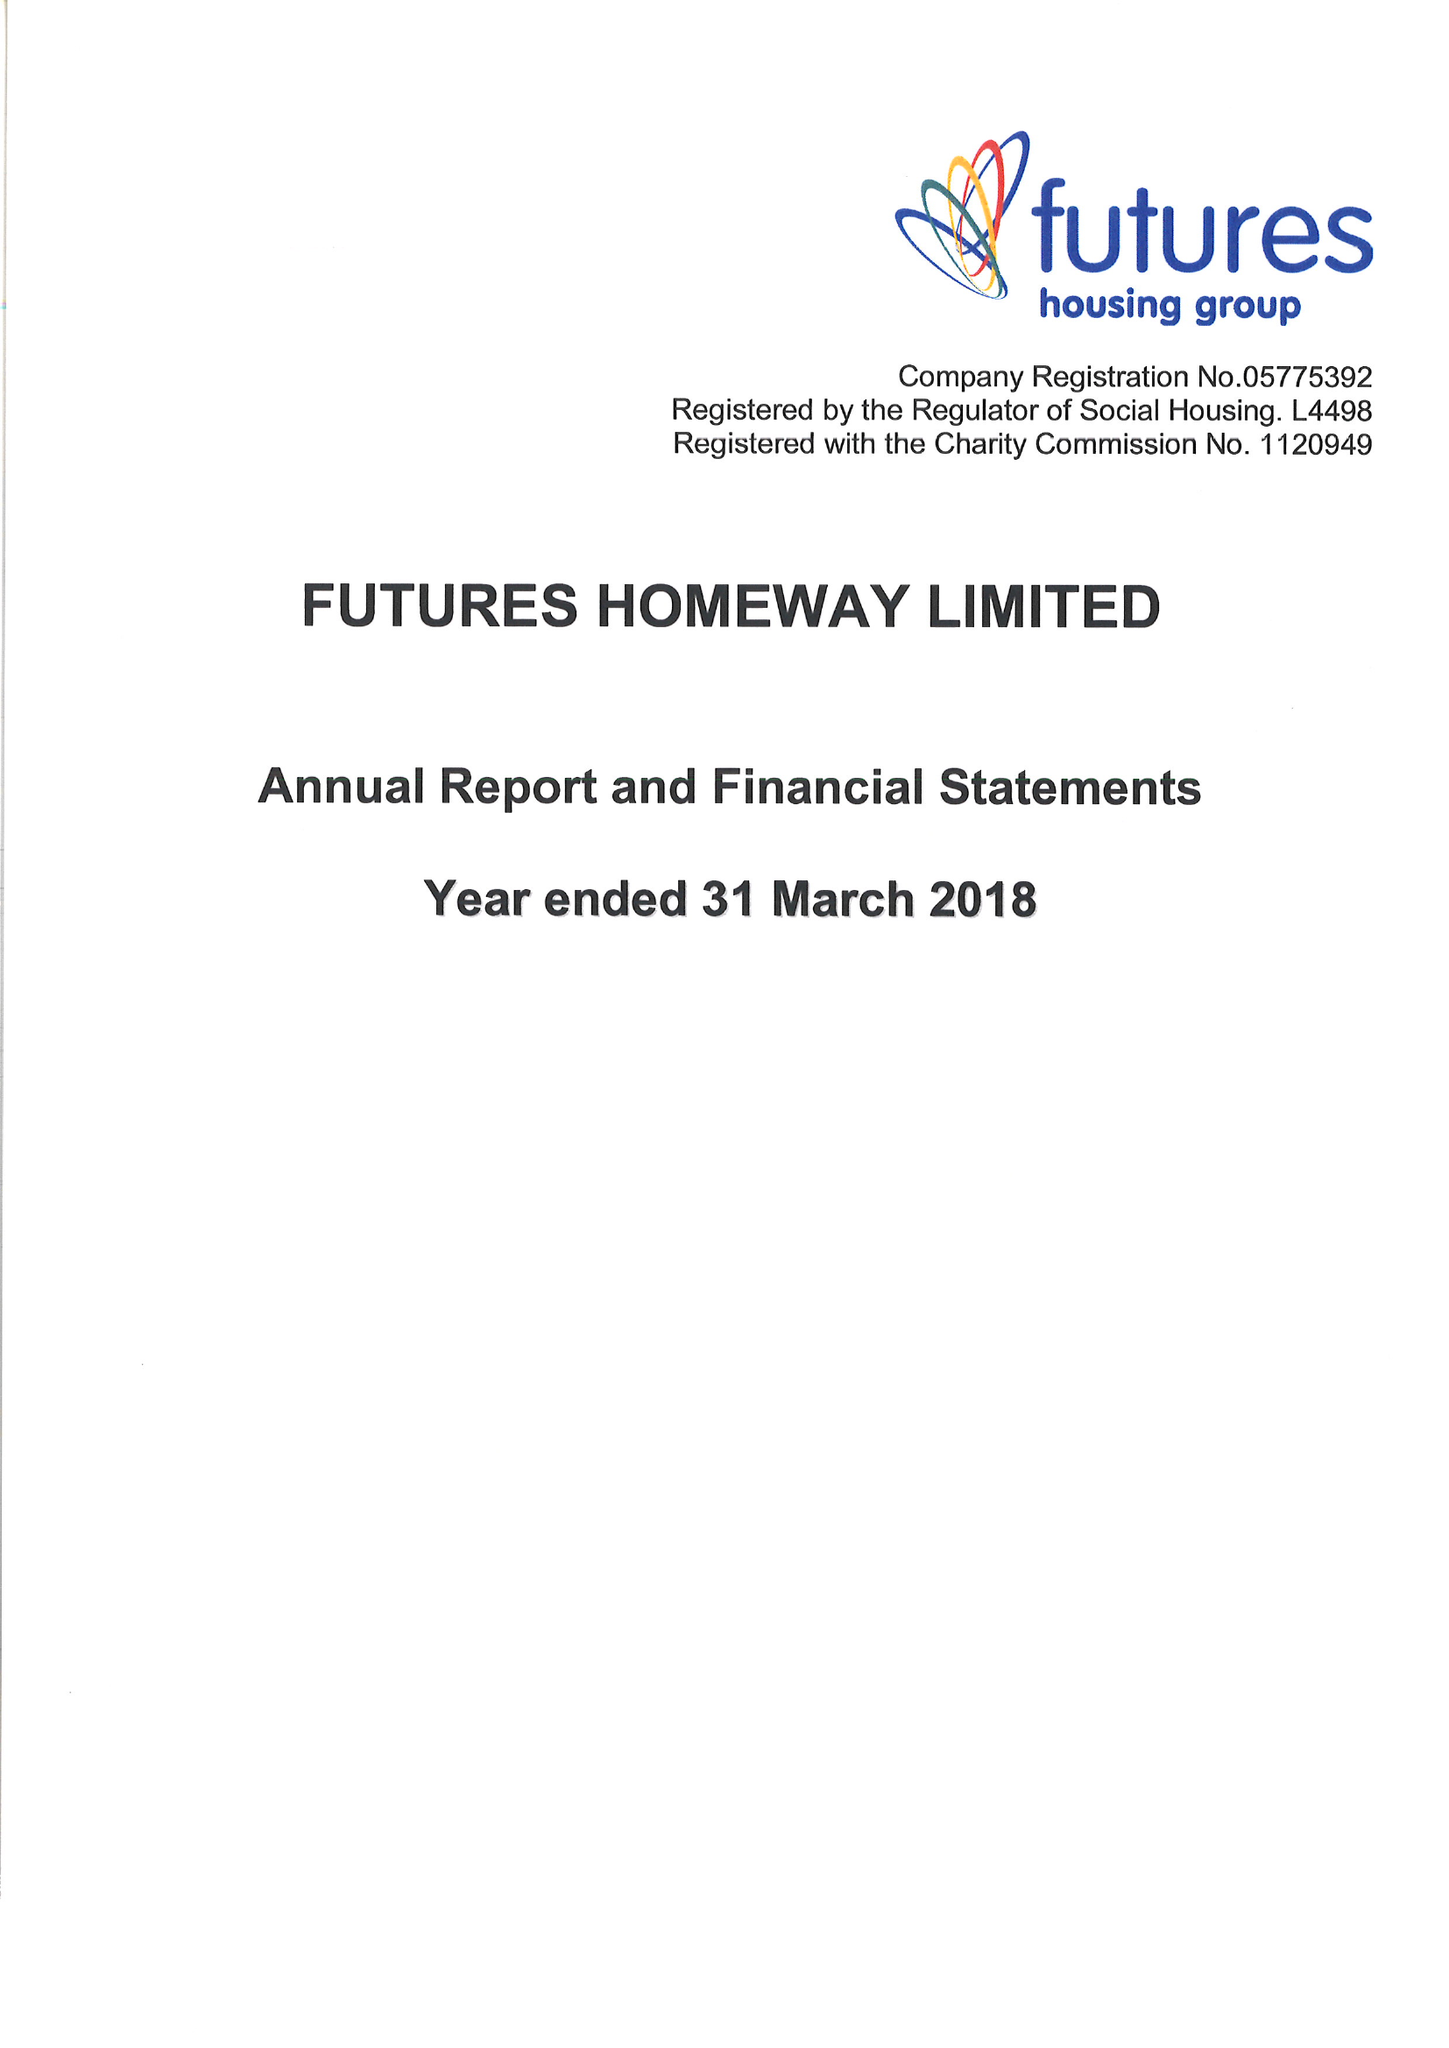What is the value for the address__post_town?
Answer the question using a single word or phrase. RIPLEY 